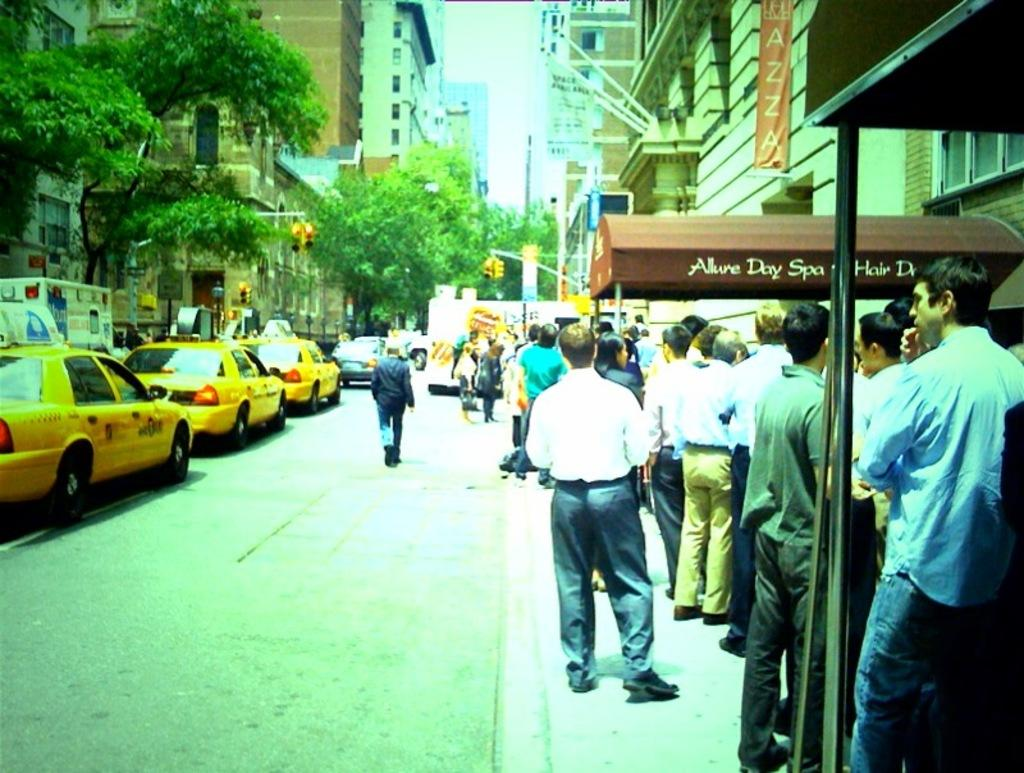<image>
Render a clear and concise summary of the photo. A crowd lines a sidewalk where the Allure Day Spa is located. 